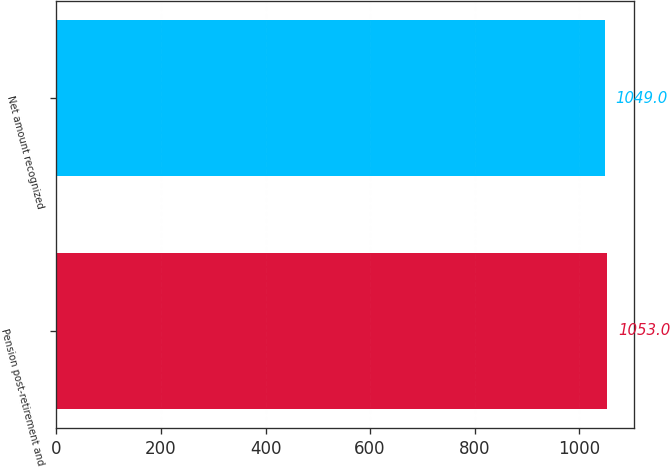Convert chart. <chart><loc_0><loc_0><loc_500><loc_500><bar_chart><fcel>Pension post-retirement and<fcel>Net amount recognized<nl><fcel>1053<fcel>1049<nl></chart> 